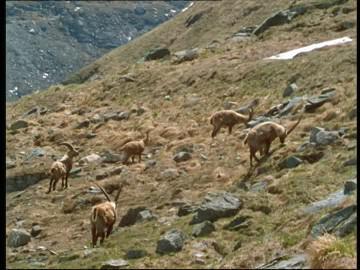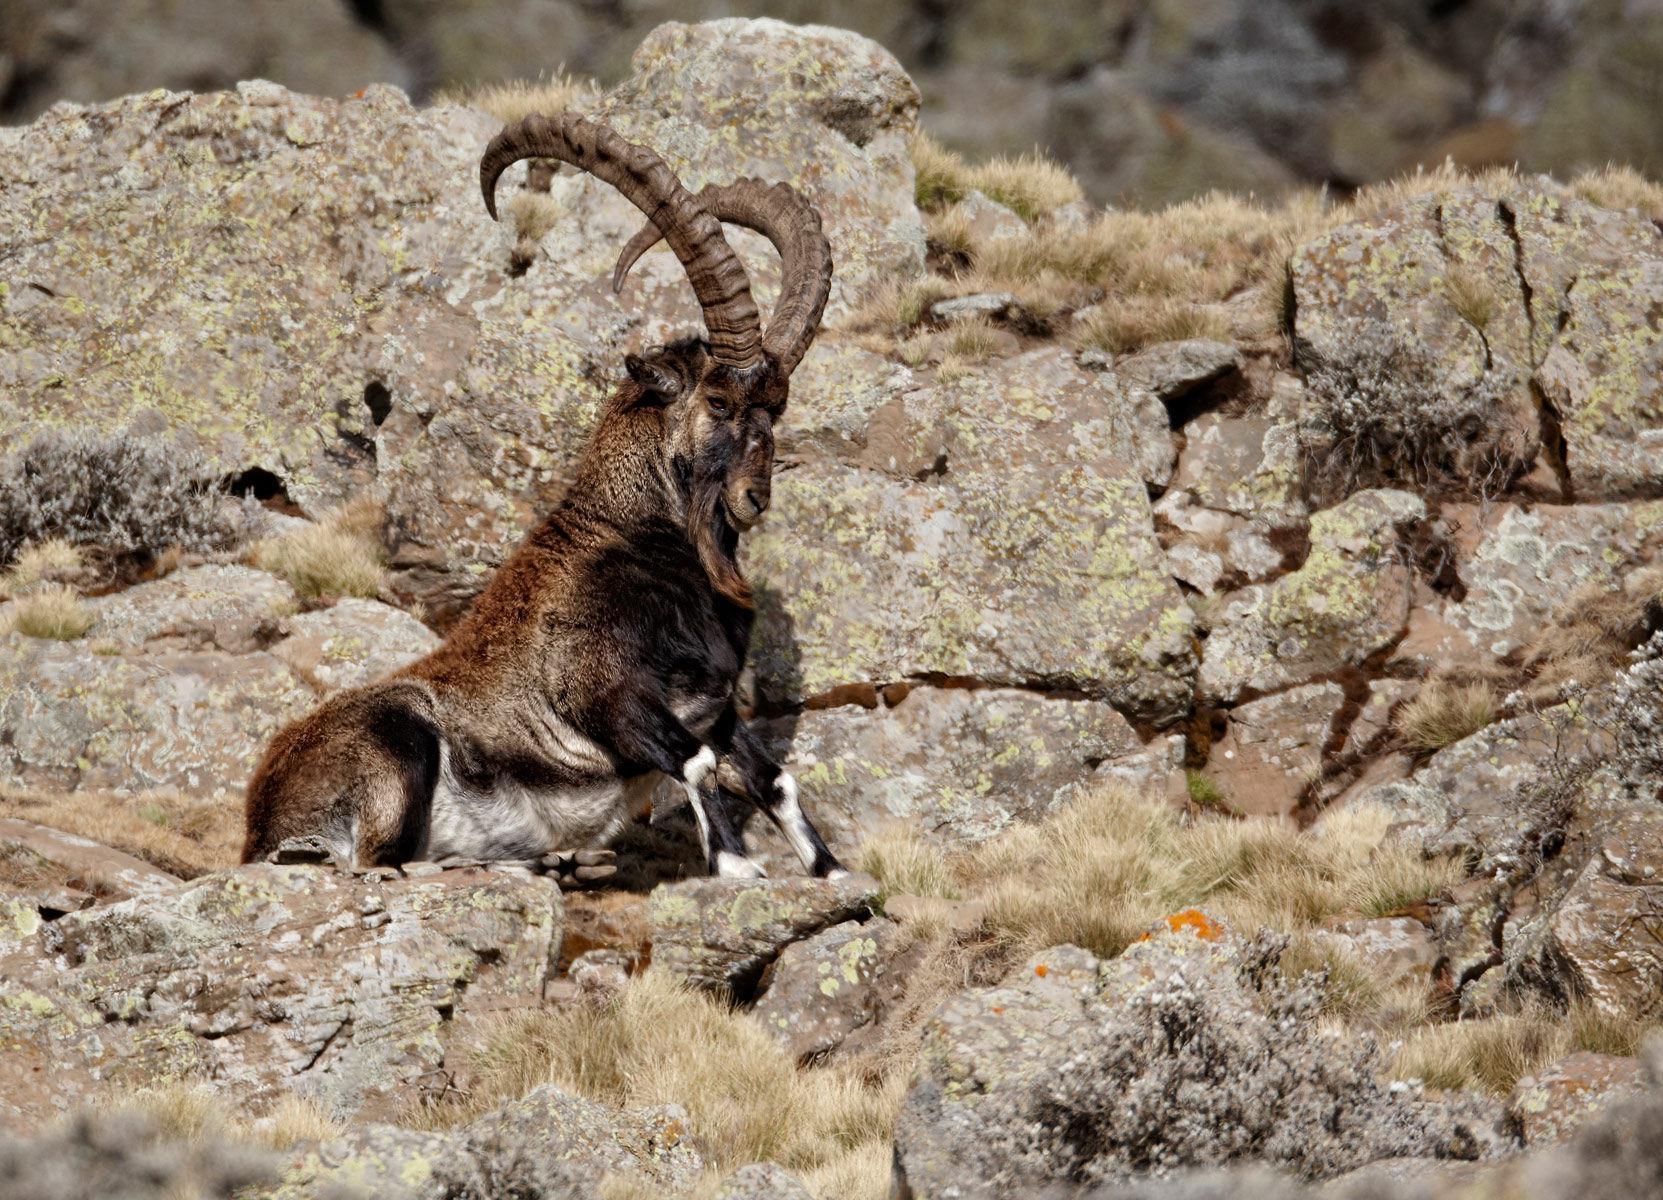The first image is the image on the left, the second image is the image on the right. Given the left and right images, does the statement "No image contains more than three hooved animals." hold true? Answer yes or no. No. The first image is the image on the left, the second image is the image on the right. Given the left and right images, does the statement "The two animals in the image on the left are horned." hold true? Answer yes or no. No. 